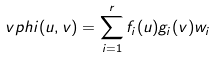<formula> <loc_0><loc_0><loc_500><loc_500>\ v p h i ( u , v ) = \sum _ { i = 1 } ^ { r } f _ { i } ( u ) g _ { i } ( v ) w _ { i }</formula> 